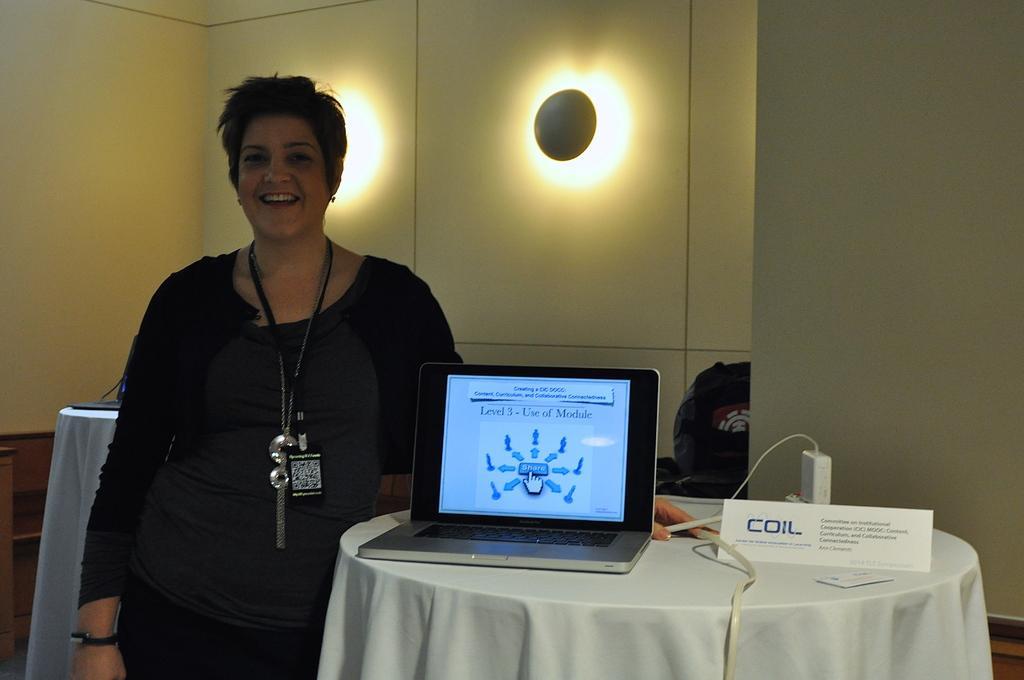In one or two sentences, can you explain what this image depicts? In this image I can see a person smiling. Beside her there is a table. On the table there is a laptop. 